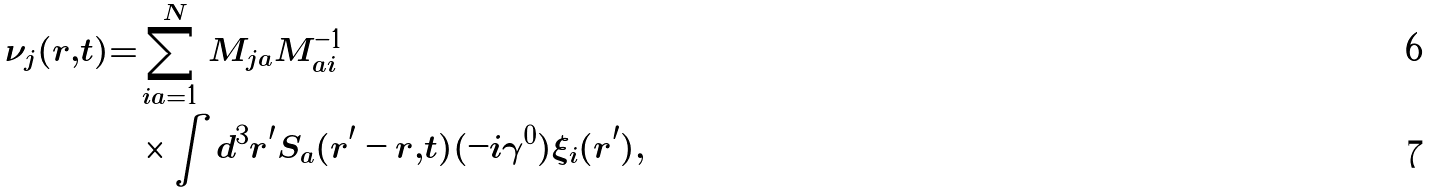Convert formula to latex. <formula><loc_0><loc_0><loc_500><loc_500>\nu _ { j } ( r , t ) = & \sum _ { i a = 1 } ^ { N } M _ { j a } M ^ { - 1 } _ { a i } \\ & \times \int d ^ { 3 } r ^ { \prime } S _ { a } ( r ^ { \prime } - r , t ) ( - i \gamma ^ { 0 } ) \xi _ { i } ( r ^ { \prime } ) ,</formula> 